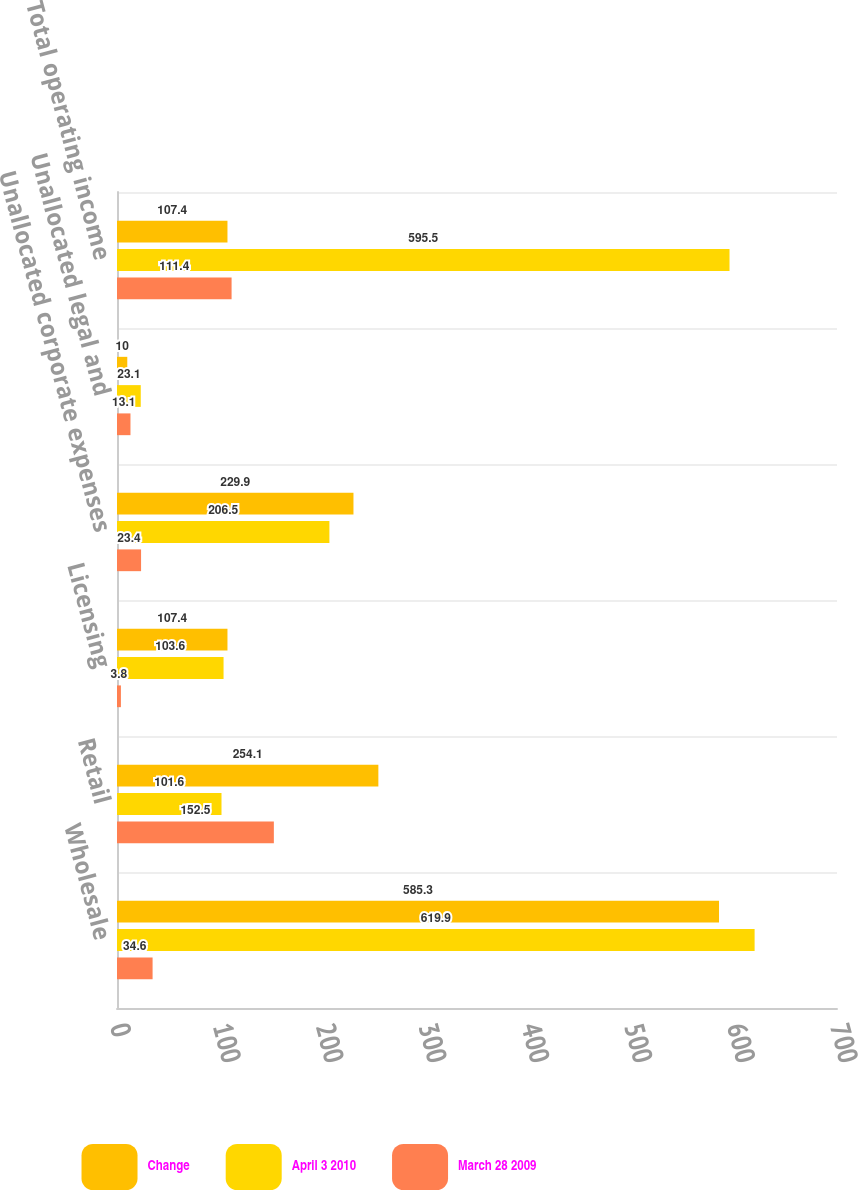Convert chart to OTSL. <chart><loc_0><loc_0><loc_500><loc_500><stacked_bar_chart><ecel><fcel>Wholesale<fcel>Retail<fcel>Licensing<fcel>Unallocated corporate expenses<fcel>Unallocated legal and<fcel>Total operating income<nl><fcel>Change<fcel>585.3<fcel>254.1<fcel>107.4<fcel>229.9<fcel>10<fcel>107.4<nl><fcel>April 3 2010<fcel>619.9<fcel>101.6<fcel>103.6<fcel>206.5<fcel>23.1<fcel>595.5<nl><fcel>March 28 2009<fcel>34.6<fcel>152.5<fcel>3.8<fcel>23.4<fcel>13.1<fcel>111.4<nl></chart> 